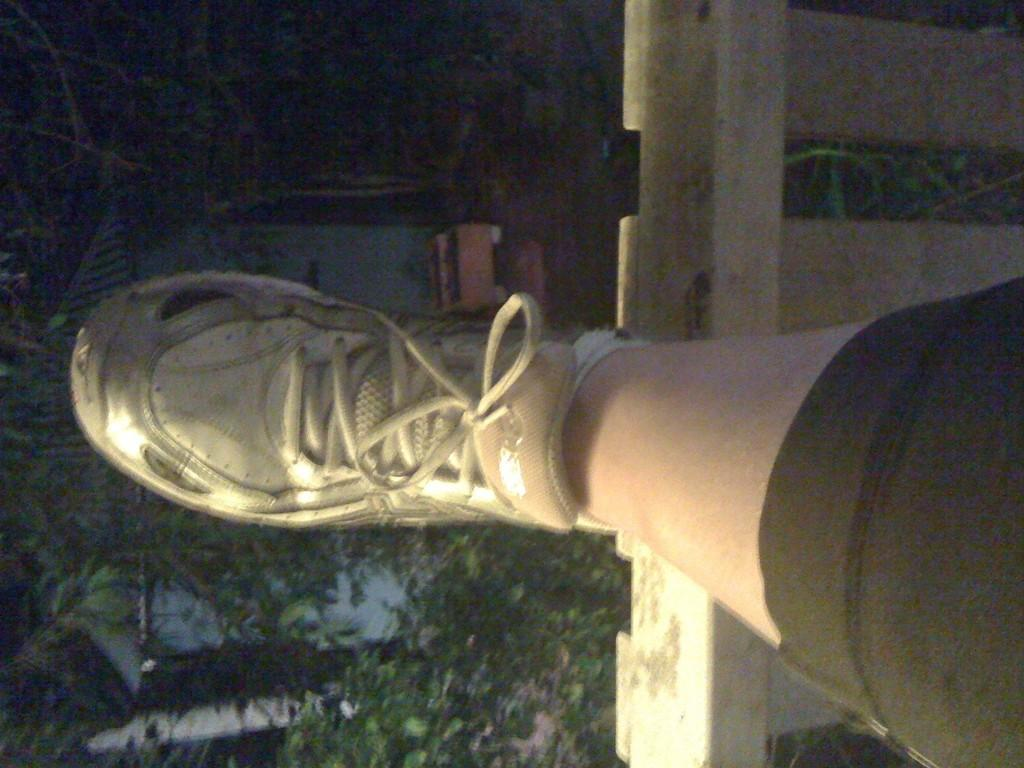What is the main subject of the image? The main subject of the image is a person's leg with a shoe. What can be seen to the left of the leg? There are plants to the left of the leg. What color is the background of the image? The background of the image is black. What type of silk fabric is draped over the books in the image? There are no books or silk fabric present in the image; it only features a person's leg with a shoe and plants to the left. 